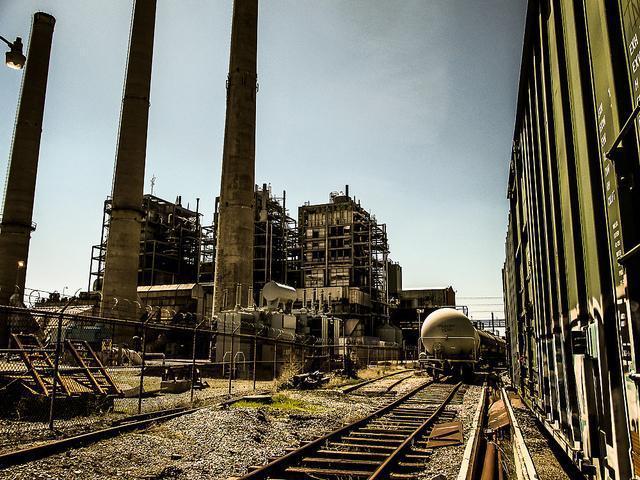How many trains are there?
Give a very brief answer. 2. 